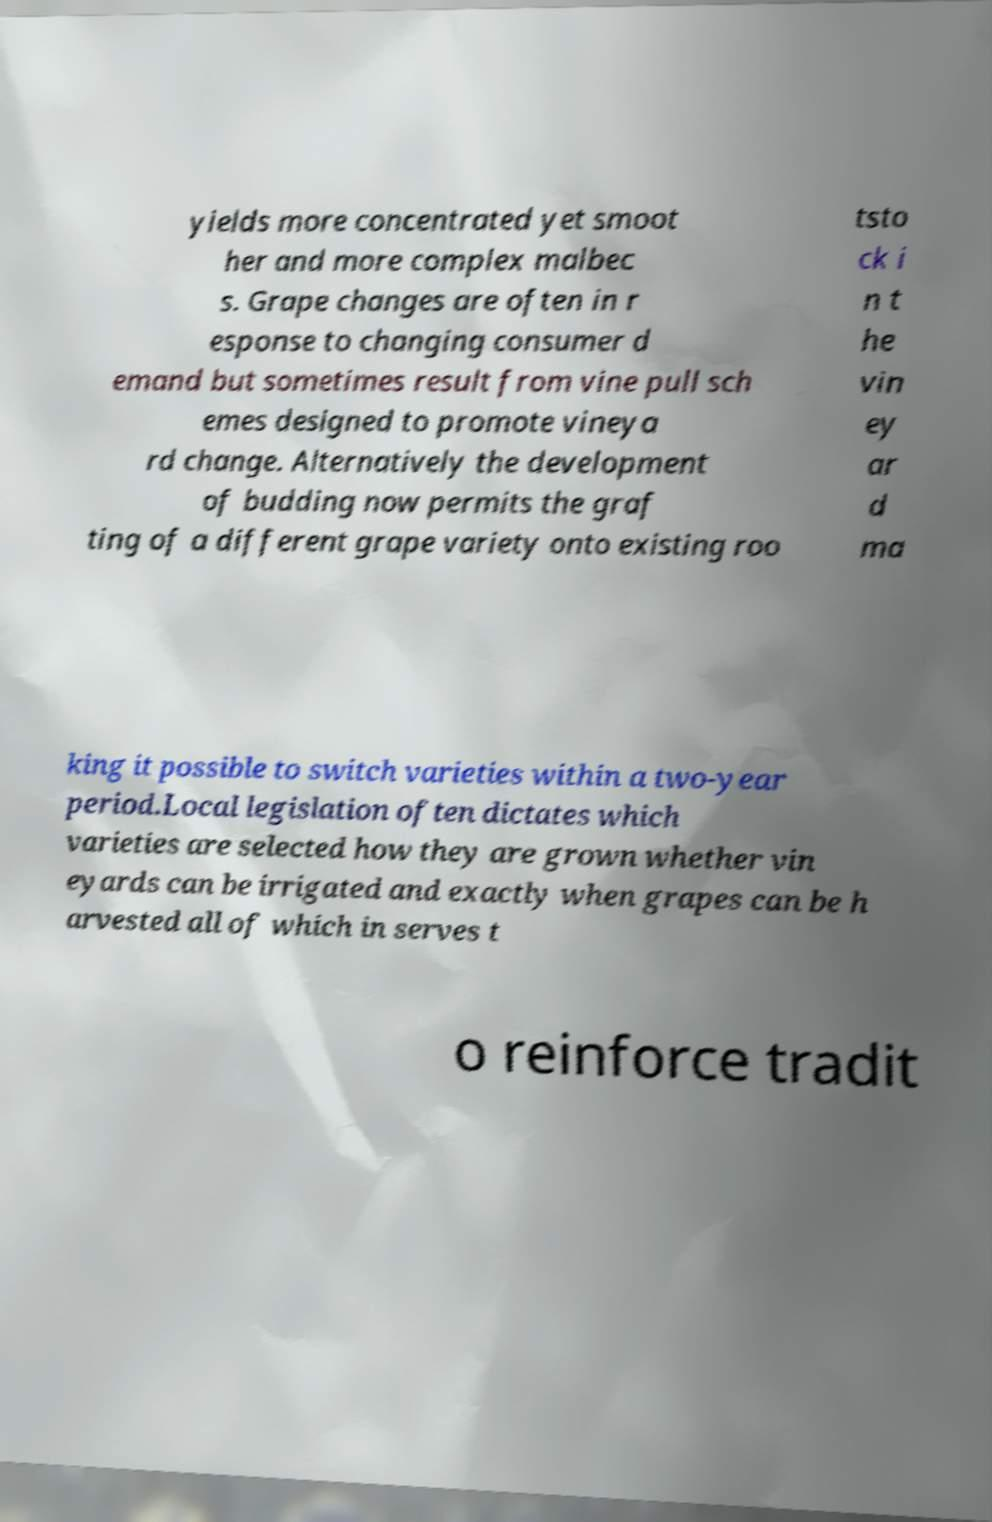Please read and relay the text visible in this image. What does it say? yields more concentrated yet smoot her and more complex malbec s. Grape changes are often in r esponse to changing consumer d emand but sometimes result from vine pull sch emes designed to promote vineya rd change. Alternatively the development of budding now permits the graf ting of a different grape variety onto existing roo tsto ck i n t he vin ey ar d ma king it possible to switch varieties within a two-year period.Local legislation often dictates which varieties are selected how they are grown whether vin eyards can be irrigated and exactly when grapes can be h arvested all of which in serves t o reinforce tradit 